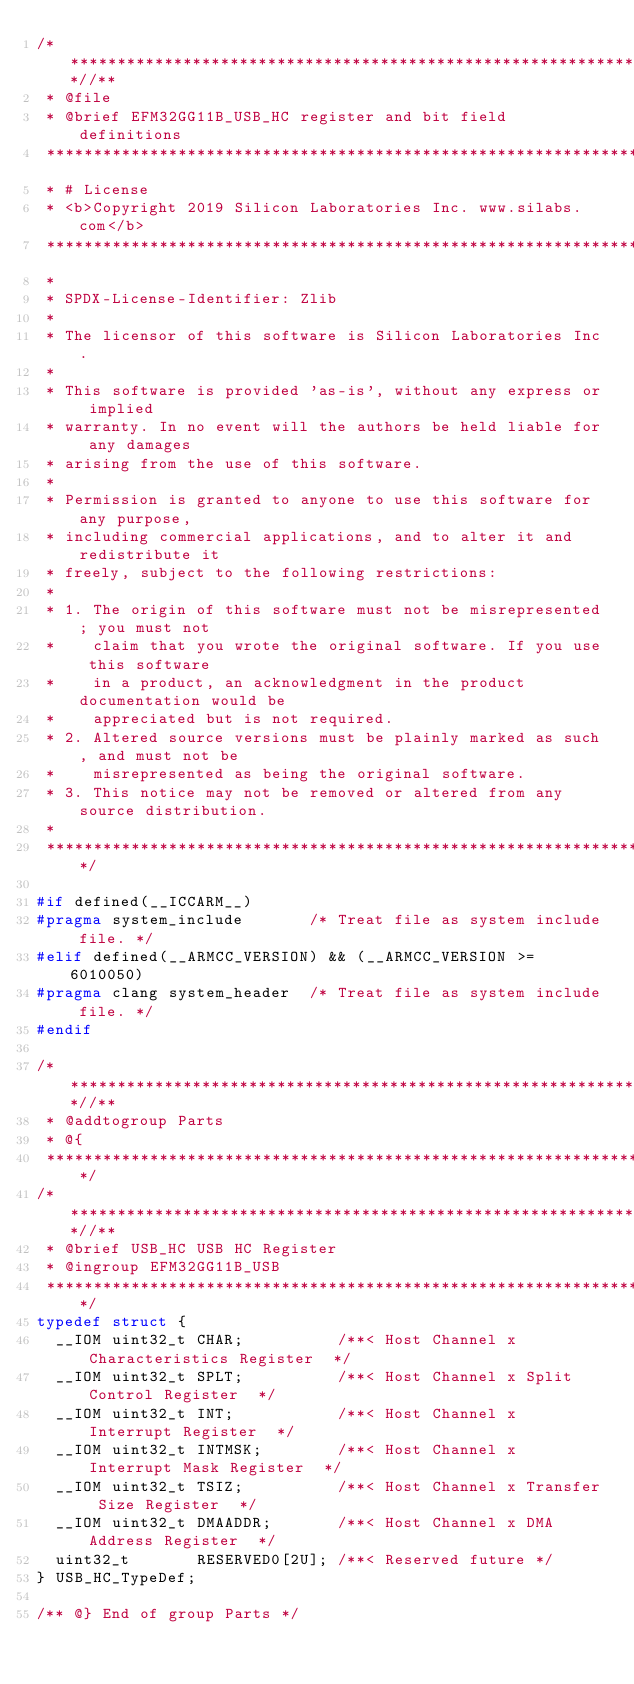<code> <loc_0><loc_0><loc_500><loc_500><_C_>/***************************************************************************//**
 * @file
 * @brief EFM32GG11B_USB_HC register and bit field definitions
 *******************************************************************************
 * # License
 * <b>Copyright 2019 Silicon Laboratories Inc. www.silabs.com</b>
 *******************************************************************************
 *
 * SPDX-License-Identifier: Zlib
 *
 * The licensor of this software is Silicon Laboratories Inc.
 *
 * This software is provided 'as-is', without any express or implied
 * warranty. In no event will the authors be held liable for any damages
 * arising from the use of this software.
 *
 * Permission is granted to anyone to use this software for any purpose,
 * including commercial applications, and to alter it and redistribute it
 * freely, subject to the following restrictions:
 *
 * 1. The origin of this software must not be misrepresented; you must not
 *    claim that you wrote the original software. If you use this software
 *    in a product, an acknowledgment in the product documentation would be
 *    appreciated but is not required.
 * 2. Altered source versions must be plainly marked as such, and must not be
 *    misrepresented as being the original software.
 * 3. This notice may not be removed or altered from any source distribution.
 *
 ******************************************************************************/

#if defined(__ICCARM__)
#pragma system_include       /* Treat file as system include file. */
#elif defined(__ARMCC_VERSION) && (__ARMCC_VERSION >= 6010050)
#pragma clang system_header  /* Treat file as system include file. */
#endif

/***************************************************************************//**
 * @addtogroup Parts
 * @{
 ******************************************************************************/
/***************************************************************************//**
 * @brief USB_HC USB HC Register
 * @ingroup EFM32GG11B_USB
 ******************************************************************************/
typedef struct {
  __IOM uint32_t CHAR;          /**< Host Channel x Characteristics Register  */
  __IOM uint32_t SPLT;          /**< Host Channel x Split Control Register  */
  __IOM uint32_t INT;           /**< Host Channel x Interrupt Register  */
  __IOM uint32_t INTMSK;        /**< Host Channel x Interrupt Mask Register  */
  __IOM uint32_t TSIZ;          /**< Host Channel x Transfer Size Register  */
  __IOM uint32_t DMAADDR;       /**< Host Channel x DMA Address Register  */
  uint32_t       RESERVED0[2U]; /**< Reserved future */
} USB_HC_TypeDef;

/** @} End of group Parts */
</code> 